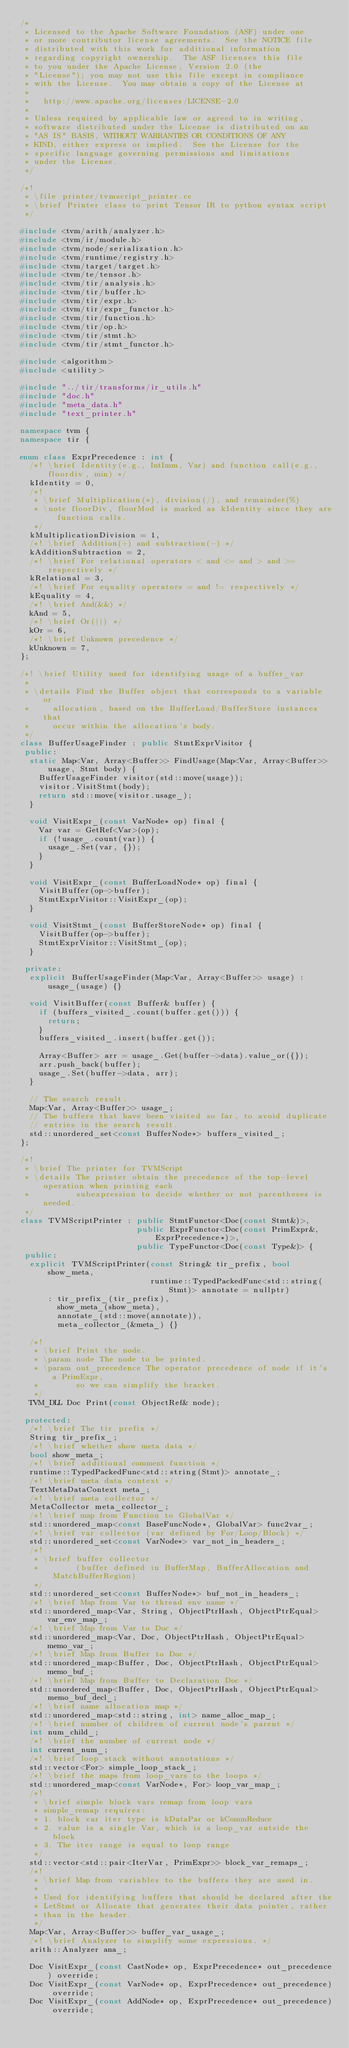<code> <loc_0><loc_0><loc_500><loc_500><_C++_>/*
 * Licensed to the Apache Software Foundation (ASF) under one
 * or more contributor license agreements.  See the NOTICE file
 * distributed with this work for additional information
 * regarding copyright ownership.  The ASF licenses this file
 * to you under the Apache License, Version 2.0 (the
 * "License"); you may not use this file except in compliance
 * with the License.  You may obtain a copy of the License at
 *
 *   http://www.apache.org/licenses/LICENSE-2.0
 *
 * Unless required by applicable law or agreed to in writing,
 * software distributed under the License is distributed on an
 * "AS IS" BASIS, WITHOUT WARRANTIES OR CONDITIONS OF ANY
 * KIND, either express or implied.  See the License for the
 * specific language governing permissions and limitations
 * under the License.
 */

/*!
 * \file printer/tvmscript_printer.cc
 * \brief Printer class to print Tensor IR to python syntax script
 */

#include <tvm/arith/analyzer.h>
#include <tvm/ir/module.h>
#include <tvm/node/serialization.h>
#include <tvm/runtime/registry.h>
#include <tvm/target/target.h>
#include <tvm/te/tensor.h>
#include <tvm/tir/analysis.h>
#include <tvm/tir/buffer.h>
#include <tvm/tir/expr.h>
#include <tvm/tir/expr_functor.h>
#include <tvm/tir/function.h>
#include <tvm/tir/op.h>
#include <tvm/tir/stmt.h>
#include <tvm/tir/stmt_functor.h>

#include <algorithm>
#include <utility>

#include "../tir/transforms/ir_utils.h"
#include "doc.h"
#include "meta_data.h"
#include "text_printer.h"

namespace tvm {
namespace tir {

enum class ExprPrecedence : int {
  /*! \brief Identity(e.g., IntImm, Var) and function call(e.g., floordiv, min) */
  kIdentity = 0,
  /*!
   * \brief Multiplication(*), division(/), and remainder(%)
   * \note floorDiv, floorMod is marked as kIdentity since they are function calls.
   */
  kMultiplicationDivision = 1,
  /*! \brief Addition(+) and subtraction(-) */
  kAdditionSubtraction = 2,
  /*! \brief For relational operators < and <= and > and >= respectively */
  kRelational = 3,
  /*! \brief For equality operators = and != respectively */
  kEquality = 4,
  /*! \brief And(&&) */
  kAnd = 5,
  /*! \brief Or(||) */
  kOr = 6,
  /*! \brief Unknown precedence */
  kUnknown = 7,
};

/*! \brief Utility used for identifying usage of a buffer_var
 *
 * \details Find the Buffer object that corresponds to a variable or
 *     allocation, based on the BufferLoad/BufferStore instances that
 *     occur within the allocation's body.
 */
class BufferUsageFinder : public StmtExprVisitor {
 public:
  static Map<Var, Array<Buffer>> FindUsage(Map<Var, Array<Buffer>> usage, Stmt body) {
    BufferUsageFinder visitor(std::move(usage));
    visitor.VisitStmt(body);
    return std::move(visitor.usage_);
  }

  void VisitExpr_(const VarNode* op) final {
    Var var = GetRef<Var>(op);
    if (!usage_.count(var)) {
      usage_.Set(var, {});
    }
  }

  void VisitExpr_(const BufferLoadNode* op) final {
    VisitBuffer(op->buffer);
    StmtExprVisitor::VisitExpr_(op);
  }

  void VisitStmt_(const BufferStoreNode* op) final {
    VisitBuffer(op->buffer);
    StmtExprVisitor::VisitStmt_(op);
  }

 private:
  explicit BufferUsageFinder(Map<Var, Array<Buffer>> usage) : usage_(usage) {}

  void VisitBuffer(const Buffer& buffer) {
    if (buffers_visited_.count(buffer.get())) {
      return;
    }
    buffers_visited_.insert(buffer.get());

    Array<Buffer> arr = usage_.Get(buffer->data).value_or({});
    arr.push_back(buffer);
    usage_.Set(buffer->data, arr);
  }

  // The search result.
  Map<Var, Array<Buffer>> usage_;
  // The buffers that have been visited so far, to avoid duplicate
  // entries in the search result.
  std::unordered_set<const BufferNode*> buffers_visited_;
};

/*!
 * \brief The printer for TVMScript
 * \details The printer obtain the precedence of the top-level operation when printing each
 *          subexpression to decide whether or not parentheses is needed.
 */
class TVMScriptPrinter : public StmtFunctor<Doc(const Stmt&)>,
                         public ExprFunctor<Doc(const PrimExpr&, ExprPrecedence*)>,
                         public TypeFunctor<Doc(const Type&)> {
 public:
  explicit TVMScriptPrinter(const String& tir_prefix, bool show_meta,
                            runtime::TypedPackedFunc<std::string(Stmt)> annotate = nullptr)
      : tir_prefix_(tir_prefix),
        show_meta_(show_meta),
        annotate_(std::move(annotate)),
        meta_collector_(&meta_) {}

  /*!
   * \brief Print the node.
   * \param node The node to be printed.
   * \param out_precedence The operator precedence of node if it's a PrimExpr,
   *        so we can simplify the bracket.
   */
  TVM_DLL Doc Print(const ObjectRef& node);

 protected:
  /*! \brief The tir prefix */
  String tir_prefix_;
  /*! \brief whether show meta data */
  bool show_meta_;
  /*! \brief additional comment function */
  runtime::TypedPackedFunc<std::string(Stmt)> annotate_;
  /*! \brief meta data context */
  TextMetaDataContext meta_;
  /*! \brief meta collector */
  MetaCollector meta_collector_;
  /*! \brief map from Function to GlobalVar */
  std::unordered_map<const BaseFuncNode*, GlobalVar> func2var_;
  /*! \brief var collector (var defined by For/Loop/Block) */
  std::unordered_set<const VarNode*> var_not_in_headers_;
  /*!
   * \brief buffer collector
   *        (buffer defined in BufferMap, BufferAllocation and MatchBufferRegion)
   */
  std::unordered_set<const BufferNode*> buf_not_in_headers_;
  /*! \brief Map from Var to thread env name */
  std::unordered_map<Var, String, ObjectPtrHash, ObjectPtrEqual> var_env_map_;
  /*! \brief Map from Var to Doc */
  std::unordered_map<Var, Doc, ObjectPtrHash, ObjectPtrEqual> memo_var_;
  /*! \brief Map from Buffer to Doc */
  std::unordered_map<Buffer, Doc, ObjectPtrHash, ObjectPtrEqual> memo_buf_;
  /*! \brief Map from Buffer to Declaration Doc */
  std::unordered_map<Buffer, Doc, ObjectPtrHash, ObjectPtrEqual> memo_buf_decl_;
  /*! \brief name allocation map */
  std::unordered_map<std::string, int> name_alloc_map_;
  /*! \brief number of children of current node's parent */
  int num_child_;
  /*! \brief the number of current node */
  int current_num_;
  /*! \brief loop stack without annotations */
  std::vector<For> simple_loop_stack_;
  /*! \brief the maps from loop_vars to the loops */
  std::unordered_map<const VarNode*, For> loop_var_map_;
  /*!
   * \brief simple block vars remap from loop vars
   * simple_remap requires:
   * 1. block var iter type is kDataPar or kCommReduce
   * 2. value is a single Var, which is a loop_var outside the block
   * 3. The iter range is equal to loop range
   */
  std::vector<std::pair<IterVar, PrimExpr>> block_var_remaps_;
  /*!
   * \brief Map from variables to the buffers they are used in.
   *
   * Used for identifying buffers that should be declared after the
   * LetStmt or Allocate that generates their data pointer, rather
   * than in the header.
   */
  Map<Var, Array<Buffer>> buffer_var_usage_;
  /*! \brief Analyzer to simplify some expressions. */
  arith::Analyzer ana_;

  Doc VisitExpr_(const CastNode* op, ExprPrecedence* out_precedence) override;
  Doc VisitExpr_(const VarNode* op, ExprPrecedence* out_precedence) override;
  Doc VisitExpr_(const AddNode* op, ExprPrecedence* out_precedence) override;</code> 